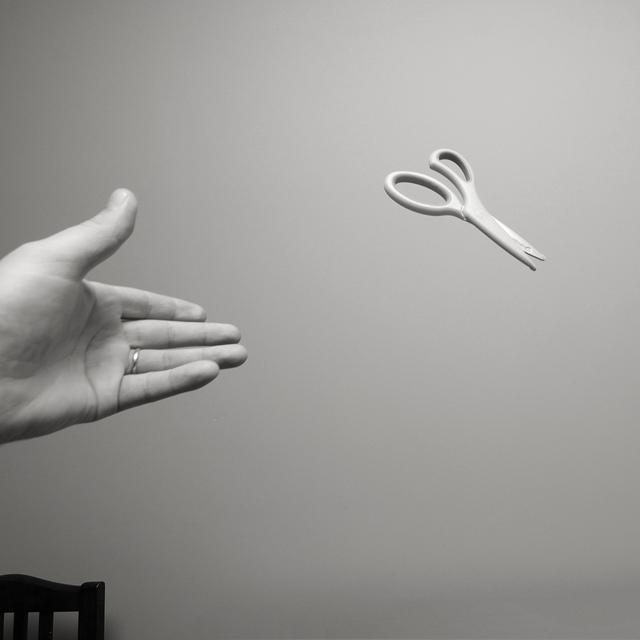How many people are visible?
Give a very brief answer. 1. How many scissors can you see?
Give a very brief answer. 1. 